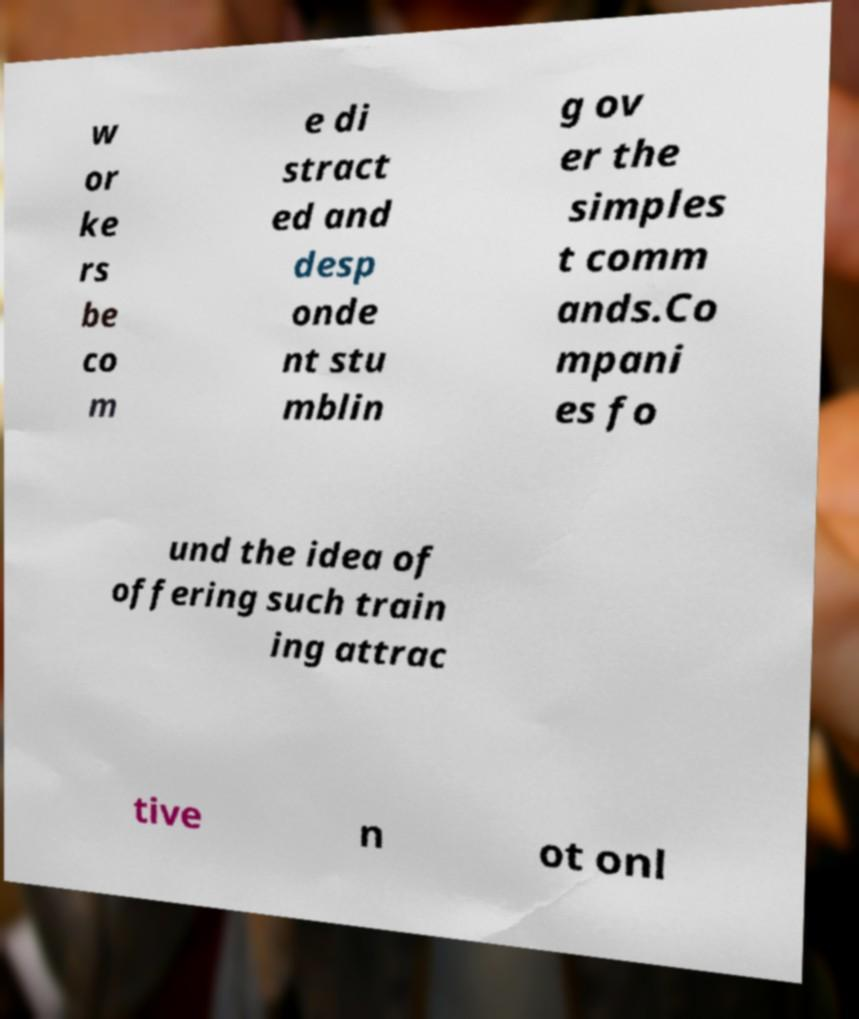Could you assist in decoding the text presented in this image and type it out clearly? w or ke rs be co m e di stract ed and desp onde nt stu mblin g ov er the simples t comm ands.Co mpani es fo und the idea of offering such train ing attrac tive n ot onl 